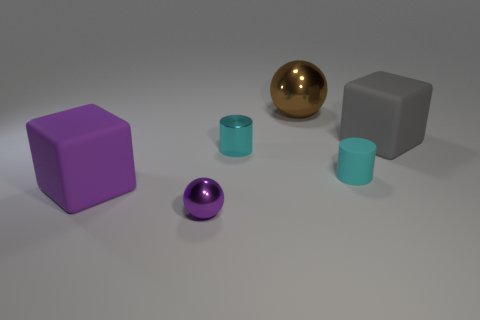Is the cube that is to the left of the brown shiny object made of the same material as the big gray block? While the cube to the left of the brown shiny object and the big gray block both have a matte surface, suggesting they could be made of similar material, we can't definitively determine material composition from a visual inspection alone. Material properties like density or composition require more information than what is visually available. 